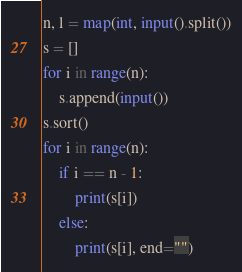<code> <loc_0><loc_0><loc_500><loc_500><_Python_>n, l = map(int, input().split())
s = []
for i in range(n):
    s.append(input())
s.sort()
for i in range(n):
    if i == n - 1:
        print(s[i])
    else:
        print(s[i], end="")
</code> 